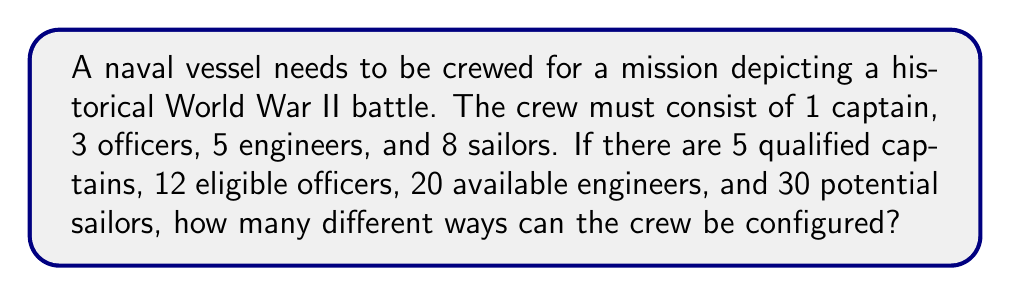Help me with this question. To solve this problem, we need to use the multiplication principle of counting. We'll break down the selection process for each role and then multiply the results together.

1. Selecting the captain:
   There are 5 qualified captains, and we need to choose 1.
   This can be done in $\binom{5}{1} = 5$ ways.

2. Selecting the officers:
   There are 12 eligible officers, and we need to choose 3.
   This can be done in $\binom{12}{3}$ ways.
   $\binom{12}{3} = \frac{12!}{3!(12-3)!} = \frac{12!}{3!9!} = 220$ ways.

3. Selecting the engineers:
   There are 20 available engineers, and we need to choose 5.
   This can be done in $\binom{20}{5}$ ways.
   $\binom{20}{5} = \frac{20!}{5!(20-5)!} = \frac{20!}{5!15!} = 15,504$ ways.

4. Selecting the sailors:
   There are 30 potential sailors, and we need to choose 8.
   This can be done in $\binom{30}{8}$ ways.
   $\binom{30}{8} = \frac{30!}{8!(30-8)!} = \frac{30!}{8!22!} = 5,852,925$ ways.

Now, we apply the multiplication principle. The total number of possible crew configurations is the product of the number of ways to select each role:

$$5 \times 220 \times 15,504 \times 5,852,925$$

This gives us the total number of possible crew configurations.
Answer: $5 \times 220 \times 15,504 \times 5,852,925 = 100,039,280,000$ possible crew configurations 